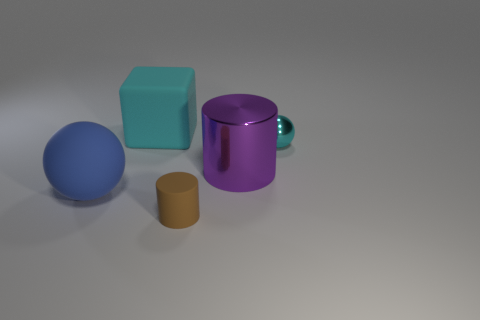What is the big purple thing made of?
Give a very brief answer. Metal. How many cyan things are behind the small ball?
Provide a short and direct response. 1. Does the block have the same color as the small metallic ball?
Ensure brevity in your answer.  Yes. How many big metallic things have the same color as the cube?
Keep it short and to the point. 0. Is the number of small green rubber objects greater than the number of purple metal cylinders?
Make the answer very short. No. What size is the rubber object that is both on the right side of the big blue rubber thing and in front of the small cyan shiny sphere?
Give a very brief answer. Small. Are the small object right of the large metal object and the big object that is right of the large cyan block made of the same material?
Provide a succinct answer. Yes. There is a blue thing that is the same size as the purple shiny object; what is its shape?
Your answer should be very brief. Sphere. Are there fewer shiny balls than metallic things?
Ensure brevity in your answer.  Yes. Is there a shiny thing that is behind the big object right of the tiny rubber cylinder?
Ensure brevity in your answer.  Yes. 